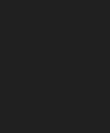Convert code to text. <code><loc_0><loc_0><loc_500><loc_500><_JavaScript_></code> 